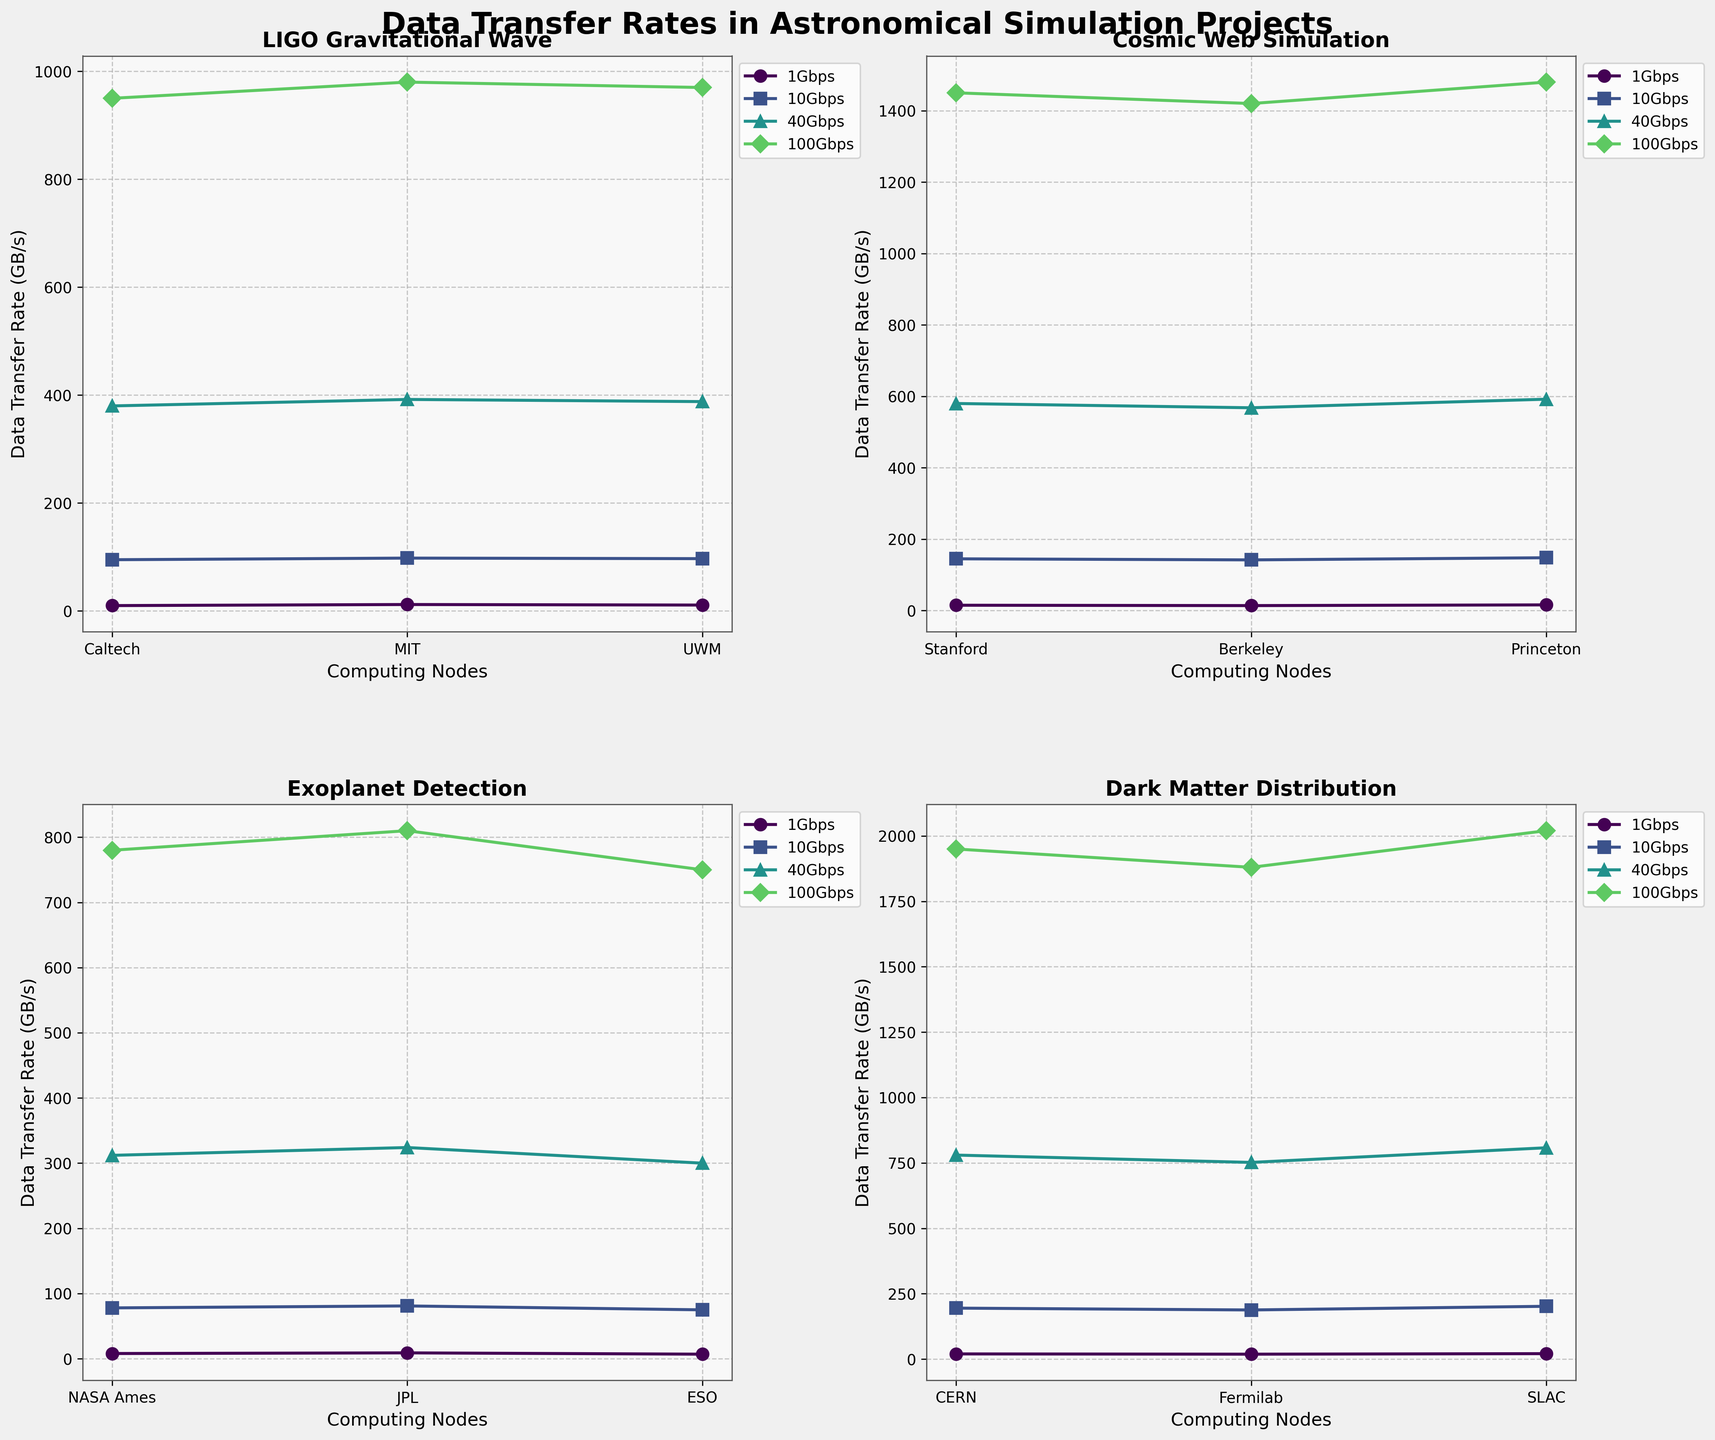What is the title of the figure? The title is located at the top center of the figure and is generally in a larger, bold font to make it stand out.
Answer: Data Transfer Rates in Astronomical Simulation Projects Which project has the highest 100Gbps data transfer rate? Examine the y-axis values of the 100Gbps lines across all subplots, focusing on the highest points for each project. Dark Matter Distribution (CERN) reaches the highest point at 2020 GB/s.
Answer: Dark Matter Distribution How does the data transfer rate of Caltech compare to MIT for the LIGO Gravitational Wave project at 10Gbps? Compare the heights of the 10Gbps lines for Caltech and MIT in the LIGO Gravitational Wave subplot. Both lines reach 95 GB/s and 98 GB/s, respectively, with MIT being slightly higher.
Answer: MIT has a higher rate What is the range of data transfer rates for the Cosmic Web Simulation project at 1Gbps? Look at the minimum and maximum values of the 1Gbps line in the Cosmic Web Simulation subplot. The lowest rate is from Berkeley at 14 GB/s, and the highest is from Princeton at 16 GB/s, giving a range of 2 GB/s.
Answer: 2 GB/s Which computing node has the highest average data transfer rate across all connection speeds for the Exoplanet Detection project? Calculate the average data transfer rates for NASA Ames, JPL, and ESO across all connection speeds (1, 10, 40, 100 Gbps). Sum the rates for each node and divide by 4. NASA Ames: (8+78+312+780)/4 = 294.5, JPL: (9+81+324+810)/4 = 306, ESO: (7+75+300+750)/4 = 283. JPL has the highest average rate.
Answer: JPL Does Stanford's 40Gbps data transfer rate fall above or below the 1300 GB/s mark in the Cosmic Web Simulation project? Locate the 40Gbps line for Stanford in the Cosmic Web Simulation subplot and find its y-value. It reaches 580 GB/s, which is well below the 1300 GB/s mark.
Answer: Below Which project shows the most significant increase in data transfer rate when moving from 1Gbps to 10Gbps? Calculate the difference between 1Gbps and 10Gbps rates for each computing node within each project, and compare the values. The difference for Dark Matter Distribution nodes is around 175. This increment is the highest among the projects shown in the figure.
Answer: Dark Matter Distribution What is the median data transfer rate for the nodes in the Cosmic Web Simulation project at 100Gbps? List the 100Gbps rates for Stanford (1450), Berkeley (1420), and Princeton (1480). Order the values to get 1420, 1450, 1480. The median is the middle value, which is 1450.
Answer: 1450 Which project has the smallest variability in data transfer rates among its nodes at 1Gbps? Check the range of data transfer rates at 1Gbps for each project by subtracting the minimum rate from the maximum rate. LIGO Gravitational Wave has rates of 10, 12, 11, which gives a range of only 2 GB/s, the smallest among the projects.
Answer: LIGO Gravitational Wave How many total subplots are present in the figure? Identify the number of distinct subplots in the grid layout of the figure: there are four (2 rows by 2 columns).
Answer: 4 